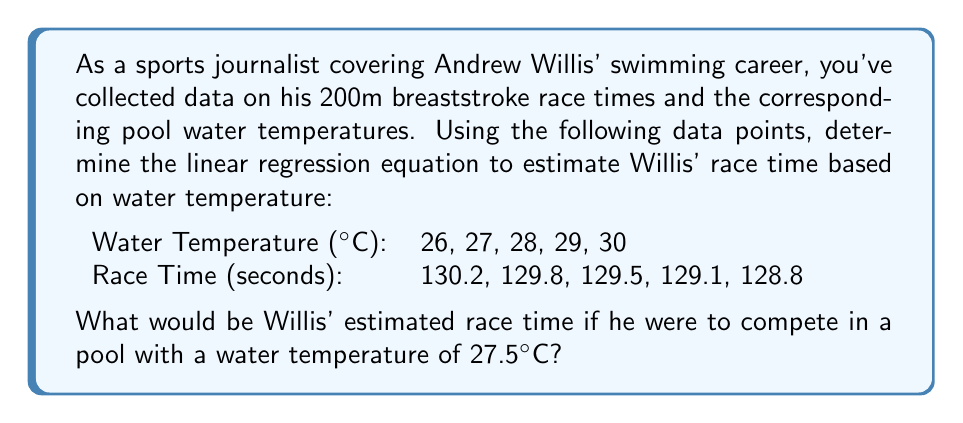Teach me how to tackle this problem. To solve this problem, we need to follow these steps:

1. Calculate the means of x (temperature) and y (race time):
   $$\bar{x} = \frac{26 + 27 + 28 + 29 + 30}{5} = 28$$
   $$\bar{y} = \frac{130.2 + 129.8 + 129.5 + 129.1 + 128.8}{5} = 129.48$$

2. Calculate the slope (m) of the regression line:
   $$m = \frac{\sum (x_i - \bar{x})(y_i - \bar{y})}{\sum (x_i - \bar{x})^2}$$

   Numerator: $(-2)(-0.72) + (-1)(-0.32) + (0)(0.02) + (1)(0.38) + (2)(0.68) = 2.16$
   Denominator: $(-2)^2 + (-1)^2 + 0^2 + 1^2 + 2^2 = 10$

   $$m = \frac{2.16}{10} = -0.34$$

3. Calculate the y-intercept (b) using the point-slope form:
   $$y - \bar{y} = m(x - \bar{x})$$
   $$129.48 = -0.34(28 - 28) + b$$
   $$b = 129.48 + 0.34(28) = 139$$

4. The linear regression equation is:
   $$y = -0.34x + 139$$

5. To estimate Willis' race time at 27.5°C, substitute x = 27.5:
   $$y = -0.34(27.5) + 139 = 129.65$$
Answer: 129.65 seconds 